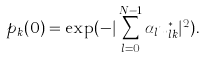<formula> <loc_0><loc_0><loc_500><loc_500>p _ { k } ( 0 ) = \exp ( - | \sum _ { l = 0 } ^ { N - 1 } \alpha _ { l } u ^ { * } _ { l k } | ^ { 2 } ) .</formula> 